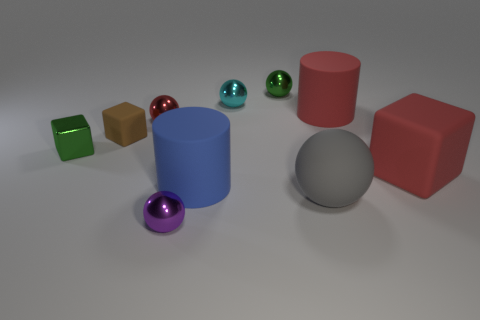Does the tiny ball that is to the right of the cyan object have the same color as the tiny shiny block?
Offer a terse response. Yes. How many other small rubber objects are the same color as the small rubber object?
Offer a terse response. 0. There is a big thing that is behind the brown cube that is left of the tiny red ball; are there any large red matte cylinders that are behind it?
Your answer should be compact. No. What is the shape of the brown rubber thing that is the same size as the cyan ball?
Your answer should be very brief. Cube. How many large things are cyan metallic things or rubber cylinders?
Offer a terse response. 2. There is a tiny cube that is made of the same material as the big gray sphere; what color is it?
Make the answer very short. Brown. There is a tiny green metallic thing on the left side of the tiny cyan ball; is it the same shape as the green object that is to the right of the brown rubber object?
Your answer should be very brief. No. How many shiny objects are tiny purple balls or blue balls?
Your response must be concise. 1. What is the material of the sphere that is the same color as the small shiny block?
Your answer should be compact. Metal. Are there any other things that have the same shape as the big gray object?
Provide a succinct answer. Yes. 